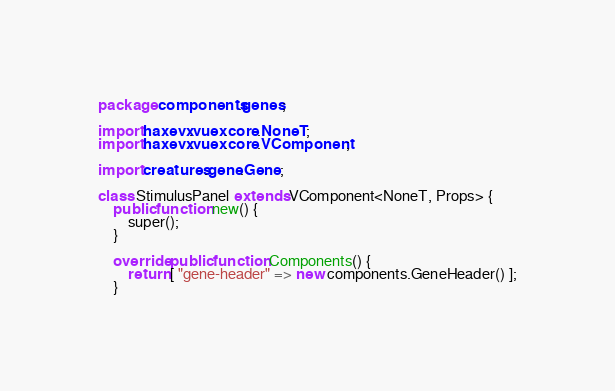<code> <loc_0><loc_0><loc_500><loc_500><_Haxe_>package components.genes;

import haxevx.vuex.core.NoneT;
import haxevx.vuex.core.VComponent;

import creatures.gene.Gene;

class StimulusPanel extends VComponent<NoneT, Props> {
    public function new() {
        super();
    }

    override public function Components() {
        return [ "gene-header" => new components.GeneHeader() ];
    }
</code> 